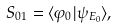<formula> <loc_0><loc_0><loc_500><loc_500>S _ { 0 1 } = \langle \varphi _ { 0 } | \psi _ { E _ { 0 } } \rangle ,</formula> 